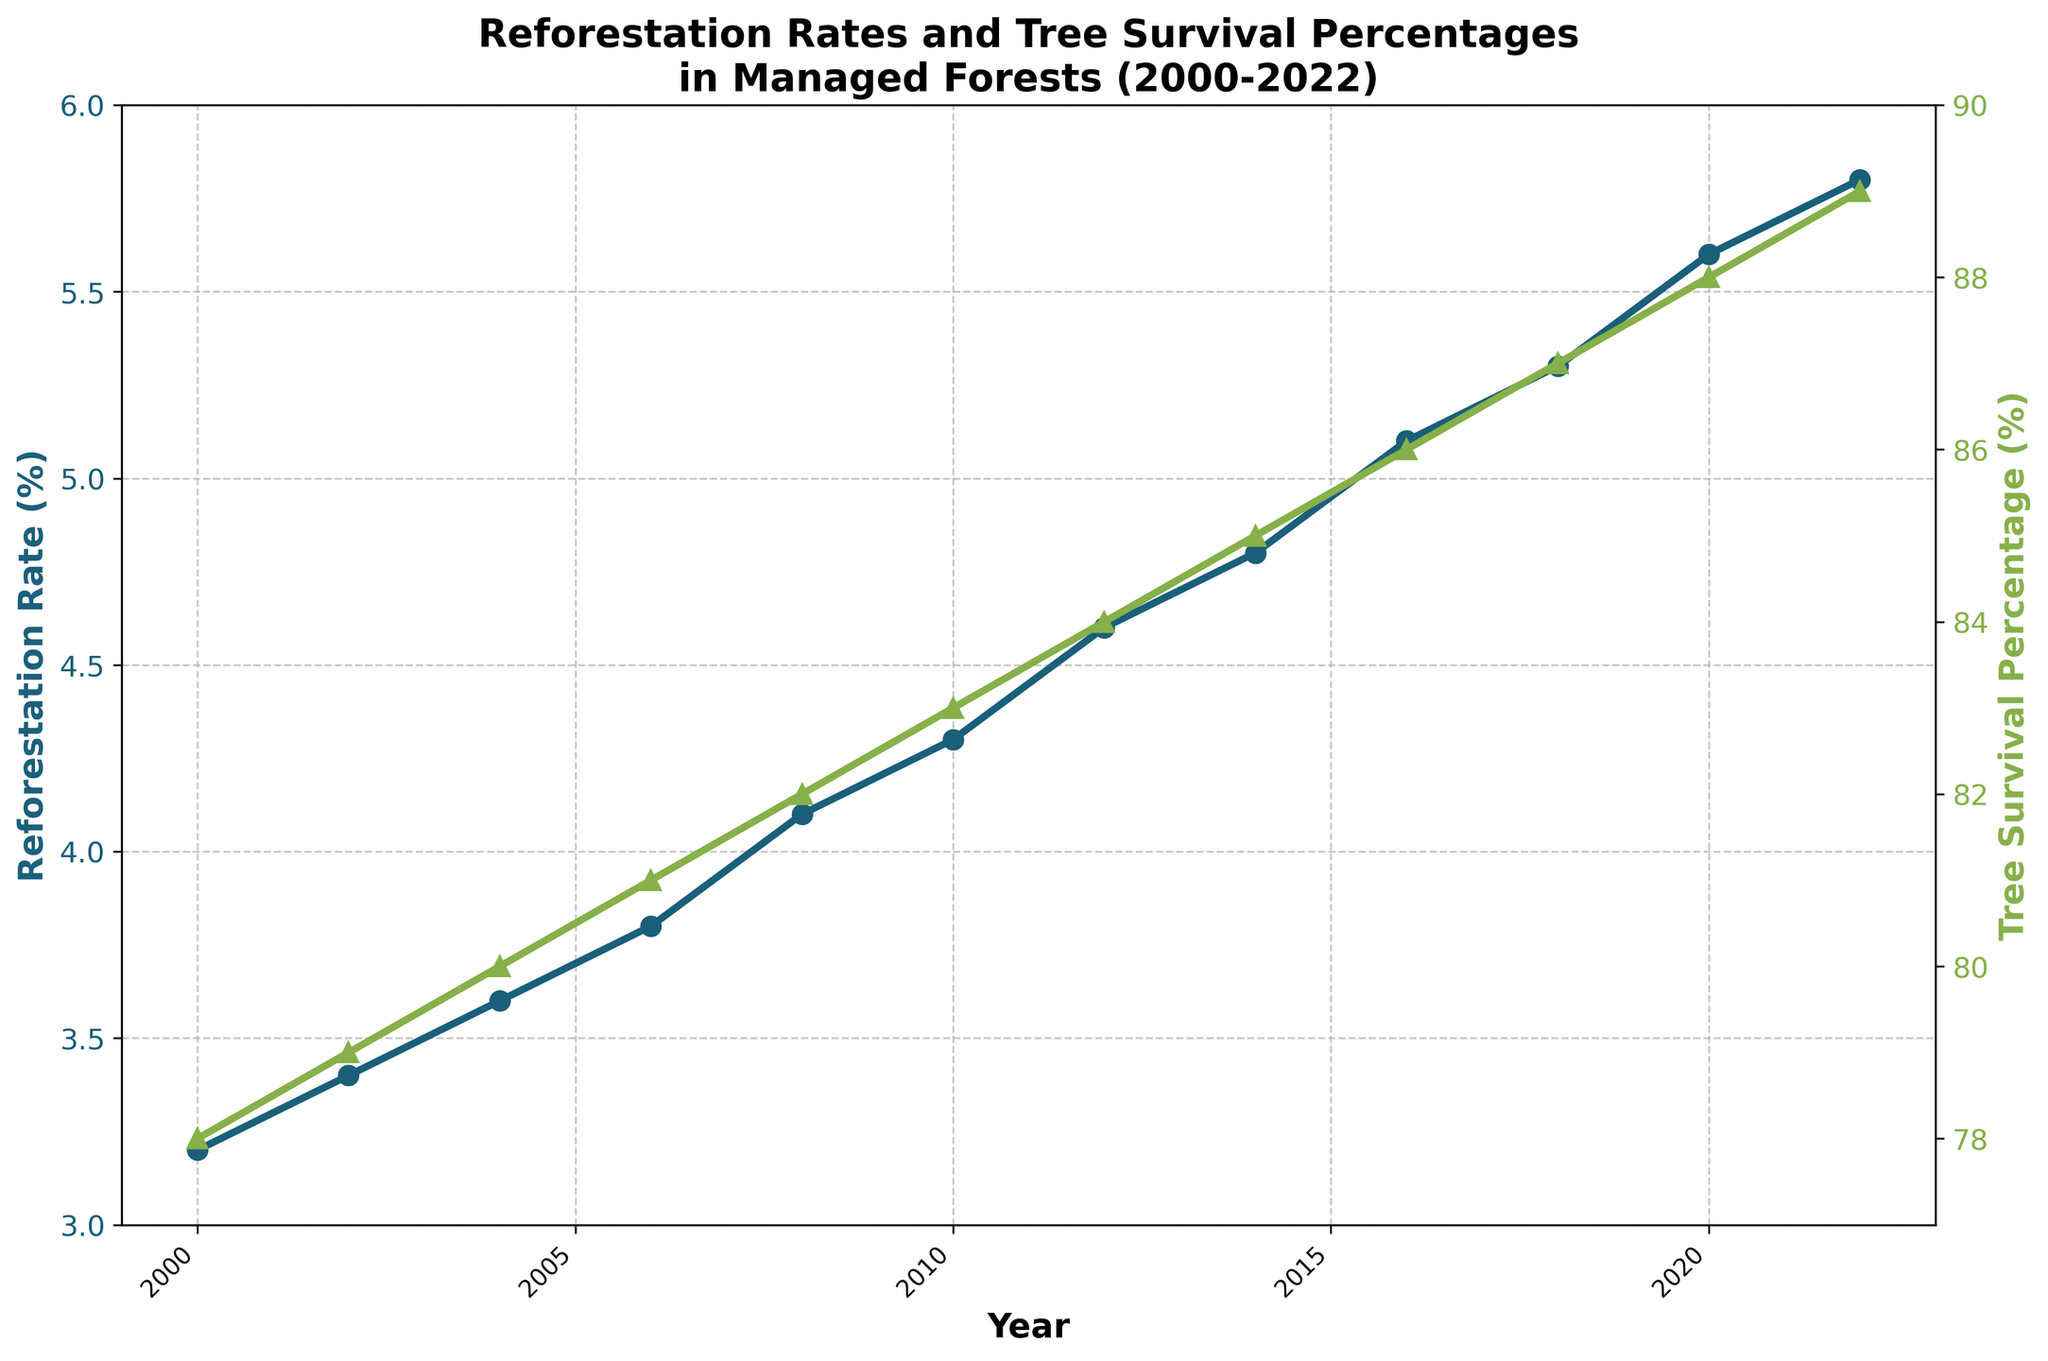What was the reforestation rate in 2010? Looking at the line marked with circles, find the point on the x-axis corresponding to the year 2010 and read the reforestation rate value from the y-axis on the left.
Answer: 4.3% How has the tree survival percentage changed from 2008 to 2012? Find the tree survival percentage for 2008 and 2012 using the line marked with triangles. The values are 82% and 84% respectively. The change is calculated by subtracting 82% from 84%.
Answer: Increased by 2% Which year had the highest reforestation rate, and what was the value? Look at the line marked with circles and locate the highest point on the y-axis on the left. The highest reforestation rate is observed in 2022, with a value of 5.8%.
Answer: 2022, 5.8% Was there a year when both reforestation rate and tree survival percentage increased compared to the previous year? Check the chart year by year. In each year increment from 2000 to 2022, both rates and percentages have increased.
Answer: Every year from 2000 to 2022 What is the overall trend in tree survival percentage from 2000 to 2022? Observe the trend of the line marked with triangles from start to end. The line consistently rises from 78% in 2000 to 89% in 2022.
Answer: Increasing trend Calculate the average reforestation rate between 2000 and 2022. Sum the reforestation rates for each year and divide by the number of years. (3.2 + 3.4 + 3.6 + 3.8 + 4.1 + 4.3 + 4.6 + 4.8 + 5.1 + 5.3 + 5.6 + 5.8) / 12 = 4.525%
Answer: 4.525% By how much did the reforestation rate increase from 2000 to 2022? Find the reforestation rates for 2000 and 2022, which are 3.2% and 5.8% respectively. Subtract the value for 2000 from 2022: 5.8% - 3.2% = 2.6%.
Answer: 2.6% In which year did the tree survival percentage surpass 85%? Trace the line marked with triangles and find the first point where the y-axis value on the right exceeds 85%. It occurs in 2014.
Answer: 2014 Compare the reforestation rates in 2006 and 2016. Which year had a higher rate and by how much? Locate the values for 2006 and 2016 which are 3.8% and 5.1% respectively. Subtract the 2006 value from the 2016 value to find the difference: 5.1% - 3.8% = 1.3%.
Answer: 2016, 1.3% What is the average tree survival percentage over the years shown? Sum the tree survival percentages for each year and divide by the number of years. (78 + 79 + 80 + 81 + 82 + 83 + 84 + 85 + 86 + 87 + 88 + 89) / 12 = 83.25%
Answer: 83.25% 